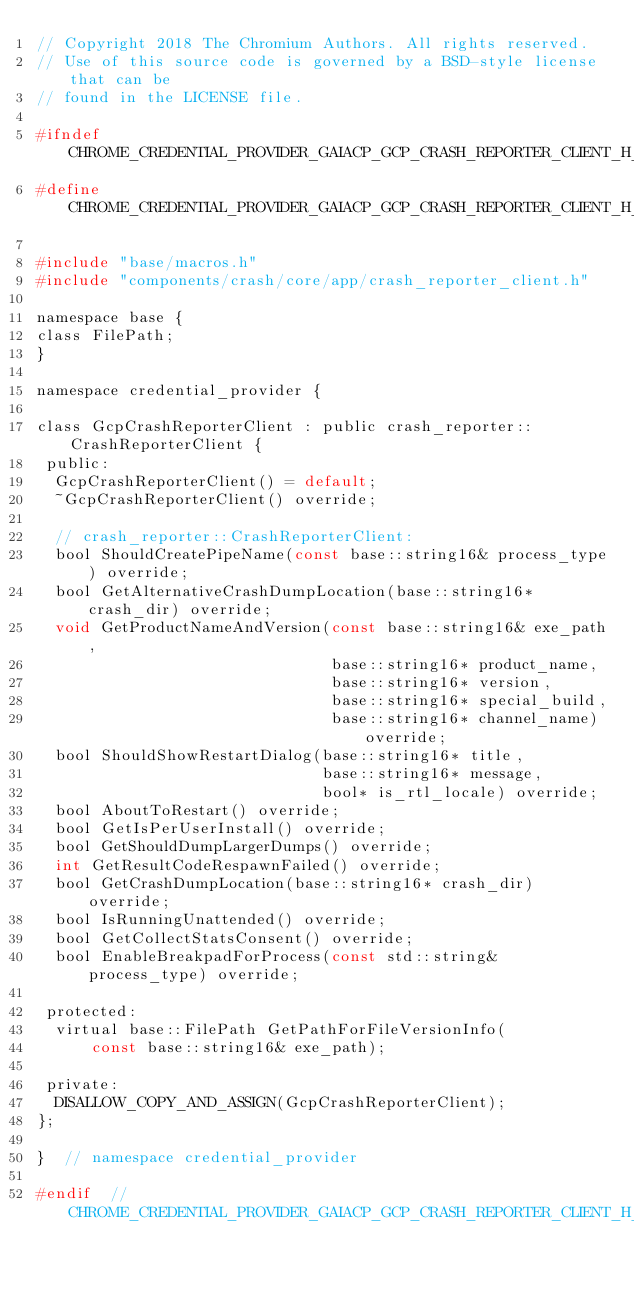<code> <loc_0><loc_0><loc_500><loc_500><_C_>// Copyright 2018 The Chromium Authors. All rights reserved.
// Use of this source code is governed by a BSD-style license that can be
// found in the LICENSE file.

#ifndef CHROME_CREDENTIAL_PROVIDER_GAIACP_GCP_CRASH_REPORTER_CLIENT_H_
#define CHROME_CREDENTIAL_PROVIDER_GAIACP_GCP_CRASH_REPORTER_CLIENT_H_

#include "base/macros.h"
#include "components/crash/core/app/crash_reporter_client.h"

namespace base {
class FilePath;
}

namespace credential_provider {

class GcpCrashReporterClient : public crash_reporter::CrashReporterClient {
 public:
  GcpCrashReporterClient() = default;
  ~GcpCrashReporterClient() override;

  // crash_reporter::CrashReporterClient:
  bool ShouldCreatePipeName(const base::string16& process_type) override;
  bool GetAlternativeCrashDumpLocation(base::string16* crash_dir) override;
  void GetProductNameAndVersion(const base::string16& exe_path,
                                base::string16* product_name,
                                base::string16* version,
                                base::string16* special_build,
                                base::string16* channel_name) override;
  bool ShouldShowRestartDialog(base::string16* title,
                               base::string16* message,
                               bool* is_rtl_locale) override;
  bool AboutToRestart() override;
  bool GetIsPerUserInstall() override;
  bool GetShouldDumpLargerDumps() override;
  int GetResultCodeRespawnFailed() override;
  bool GetCrashDumpLocation(base::string16* crash_dir) override;
  bool IsRunningUnattended() override;
  bool GetCollectStatsConsent() override;
  bool EnableBreakpadForProcess(const std::string& process_type) override;

 protected:
  virtual base::FilePath GetPathForFileVersionInfo(
      const base::string16& exe_path);

 private:
  DISALLOW_COPY_AND_ASSIGN(GcpCrashReporterClient);
};

}  // namespace credential_provider

#endif  // CHROME_CREDENTIAL_PROVIDER_GAIACP_GCP_CRASH_REPORTER_CLIENT_H_
</code> 